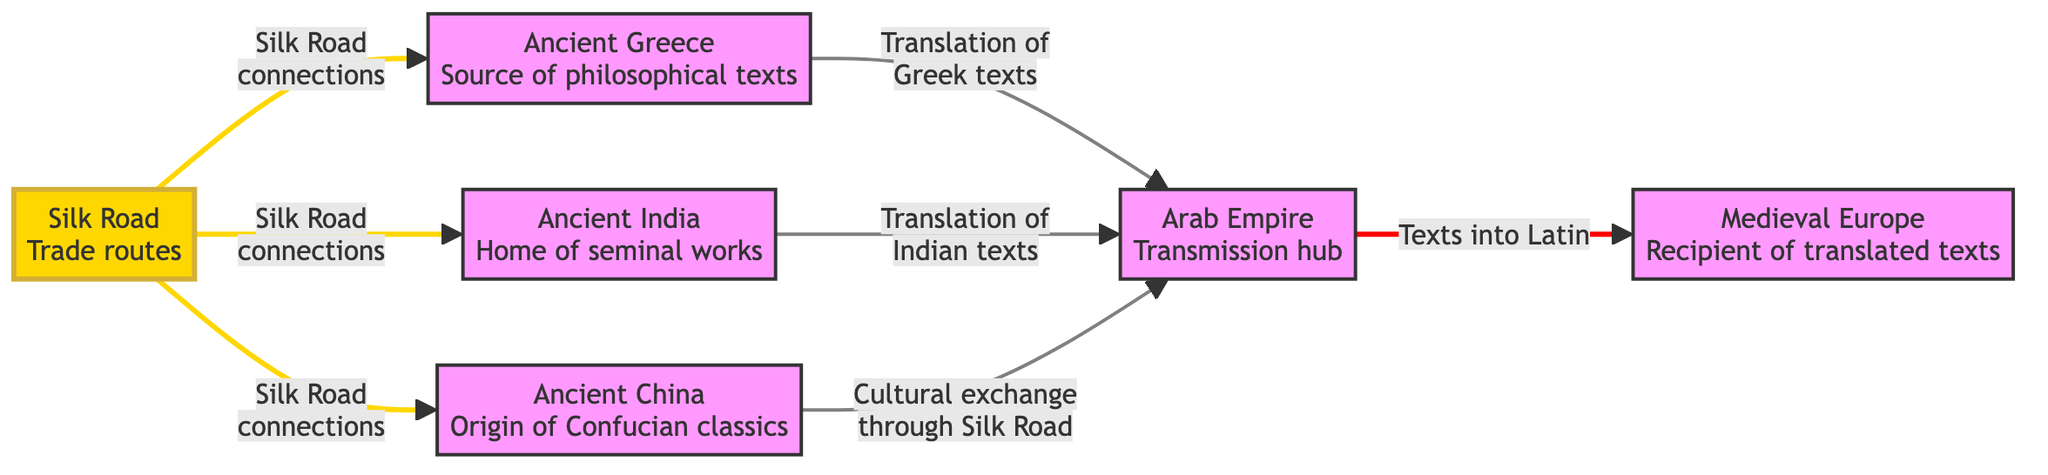What is the main source of philosophical texts in the diagram? The first node indicates that Ancient Greece is the main source of philosophical texts. It is clearly labeled as "Ancient Greece<br/>Source of philosophical texts."
Answer: Ancient Greece How many ancient civilizations are indicated in the diagram? There are five distinct civilizations represented in the diagram: Ancient Greece, Ancient India, Ancient China, Arab Empire, and Medieval Europe.
Answer: Five What is the role of the Silk Road in this diagram? The Silk Road is depicted as a trade route that facilitates cultural exchange and connections between Ancient Greece, Ancient India, and Ancient China.
Answer: Trade route Which ancient civilization translated Greek texts into Latin? The arrow pointing from the Arab Empire to Medieval Europe specifies that the texts were translated into Latin there.
Answer: Medieval Europe What type of texts did the Arab Empire act as a transmission hub for? The connections indicate that the Arab Empire is a hub for translations of Greek and Indian texts as well as cultural exchange from Ancient China.
Answer: Translations Which connections are highlighted in red within the diagram? There is a specific connection depicted in red; it represents cultural exchange through the Silk Road. This is indicated on the path from Ancient China to the Arab Empire.
Answer: Cultural exchange How many connections does the Silk Road have in the diagram? The Silk Road has three connections, illustrated with arrows leading to Ancient Greece, Ancient India, and Ancient China, showing how it links these civilizations.
Answer: Three What is the end point of the transmission process represented in the diagram? The end point of this transmission process is Medieval Europe, as indicated by the arrow from the Arab Empire leading to it for the reception of translated texts.
Answer: Medieval Europe What colors are used to represent the Silk Road in the diagram? The Silk Road is highlighted with a golden yellow fill and golden yellow stroke, distinguishing it from other nodes and connections.
Answer: Golden yellow 